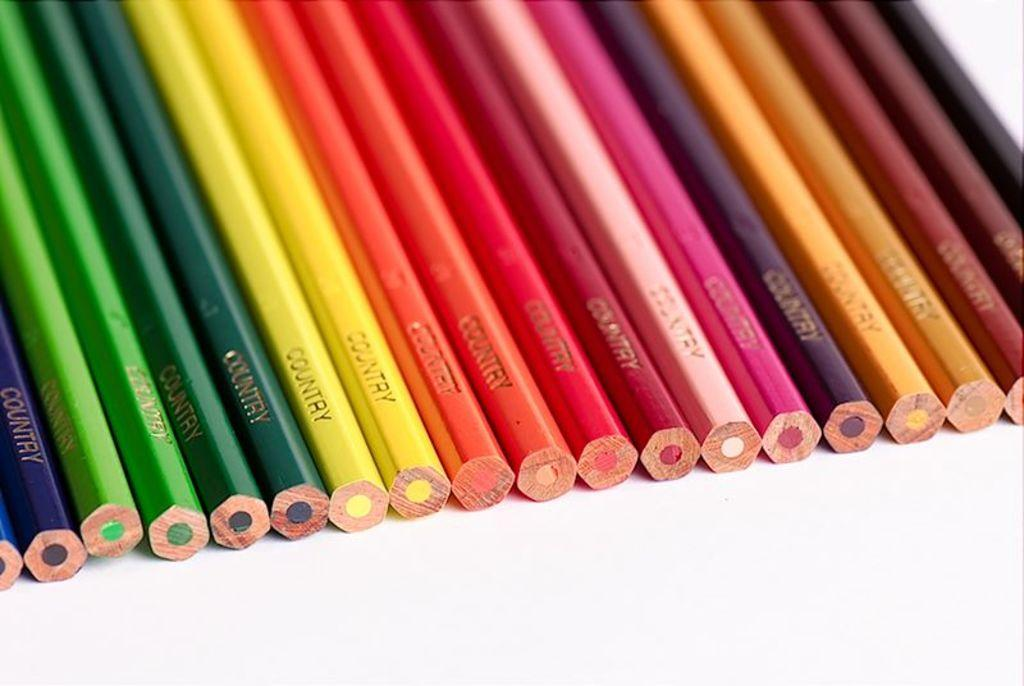<image>
Create a compact narrative representing the image presented. a few pencils with the word country on it 